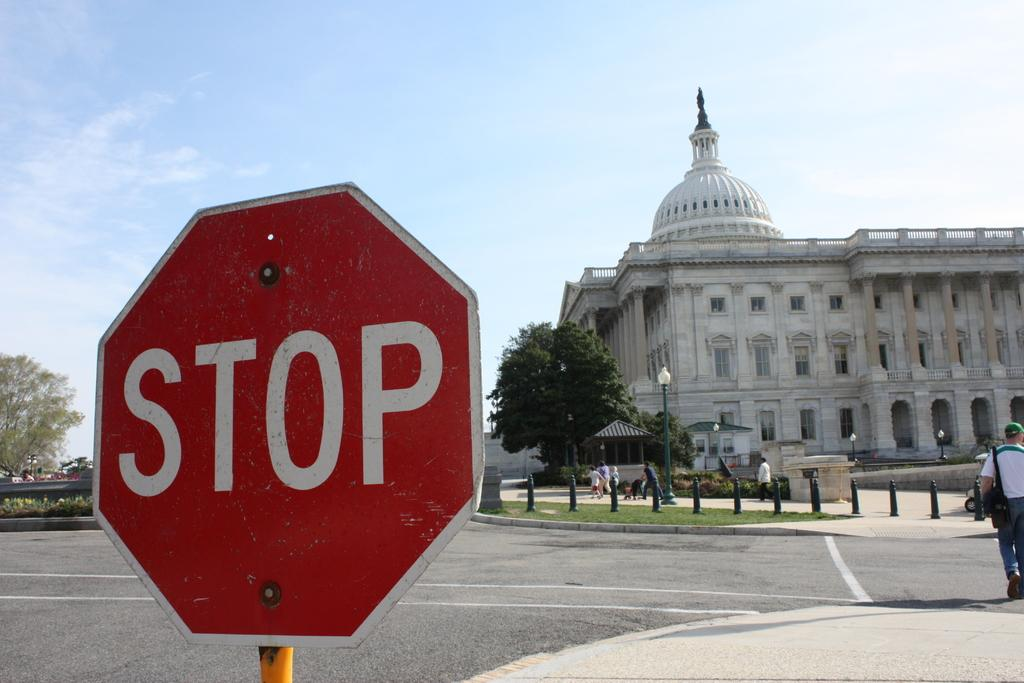<image>
Present a compact description of the photo's key features. A white and red stop sign is standing on a intersection with a large building behind it. 